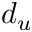Convert formula to latex. <formula><loc_0><loc_0><loc_500><loc_500>d _ { u }</formula> 